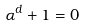<formula> <loc_0><loc_0><loc_500><loc_500>\alpha ^ { d } + 1 = 0</formula> 